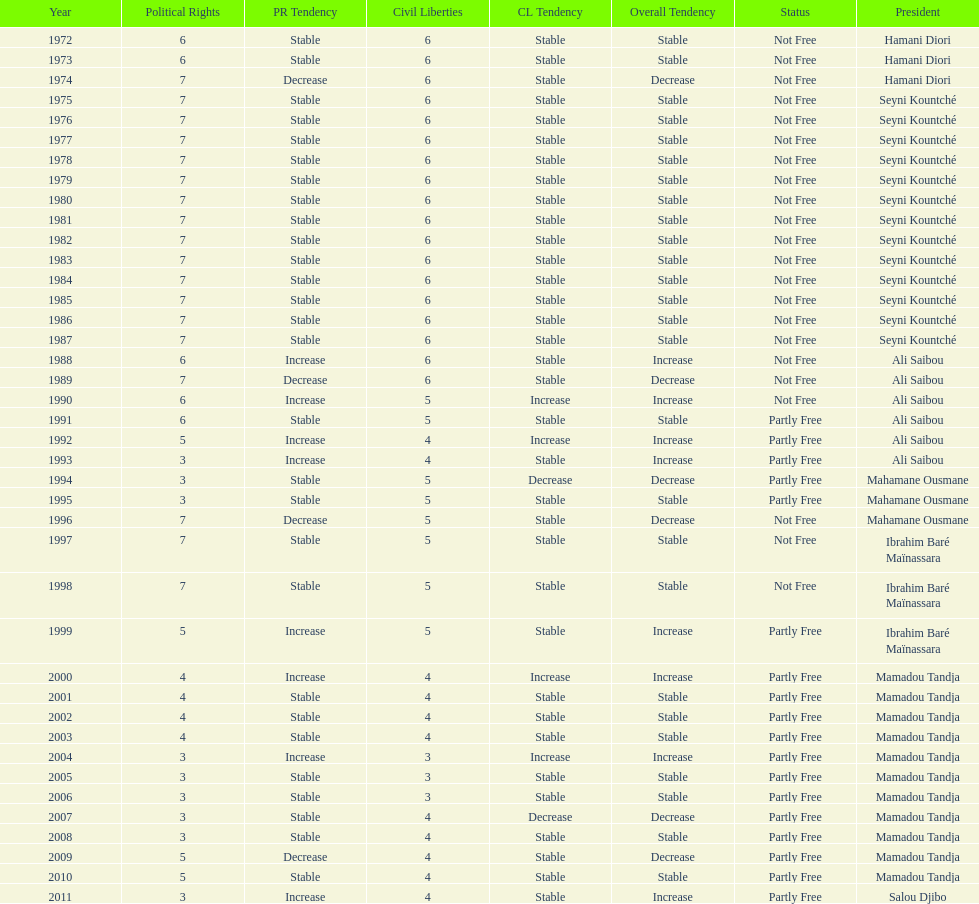How many years was ali saibou president? 6. 